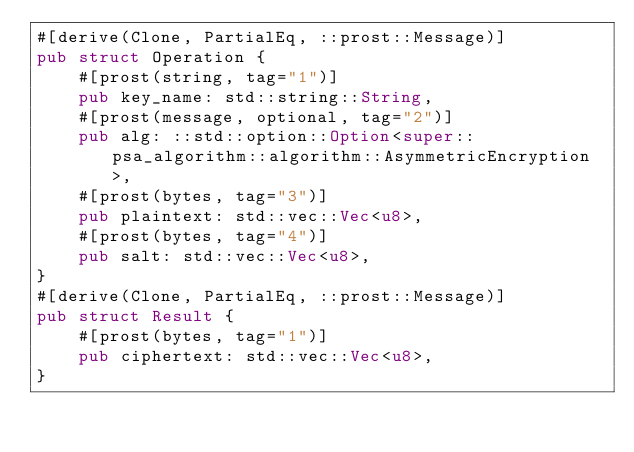Convert code to text. <code><loc_0><loc_0><loc_500><loc_500><_Rust_>#[derive(Clone, PartialEq, ::prost::Message)]
pub struct Operation {
    #[prost(string, tag="1")]
    pub key_name: std::string::String,
    #[prost(message, optional, tag="2")]
    pub alg: ::std::option::Option<super::psa_algorithm::algorithm::AsymmetricEncryption>,
    #[prost(bytes, tag="3")]
    pub plaintext: std::vec::Vec<u8>,
    #[prost(bytes, tag="4")]
    pub salt: std::vec::Vec<u8>,
}
#[derive(Clone, PartialEq, ::prost::Message)]
pub struct Result {
    #[prost(bytes, tag="1")]
    pub ciphertext: std::vec::Vec<u8>,
}
</code> 